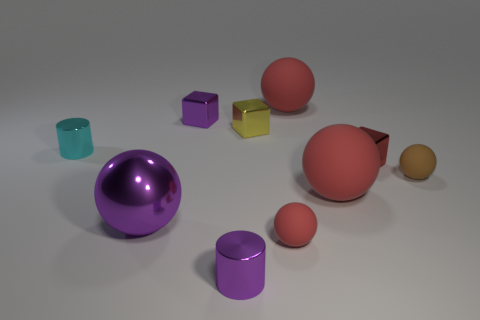Do the cyan object and the purple thing behind the tiny red metal object have the same size? Based on the perspective in the image, it appears that the cyan cylinder and the purple cube are roughly similar in size, although it's difficult to determine exact dimensions without additional information or context. Both objects exhibit simple geometric shapes, which allows for a comparison, and considering perspective, they seem to maintain similar proportions. 